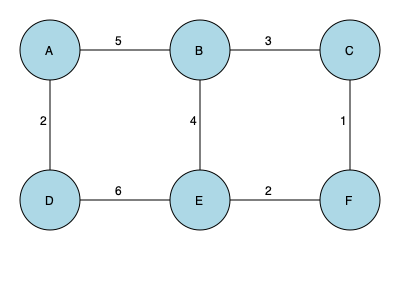Given the network topology represented by the graph above, where nodes represent servers and edge weights represent latency in milliseconds, what is the minimum spanning tree (MST) weight that ensures optimal connectivity with minimal total latency? To find the minimum spanning tree (MST) weight, we'll use Kruskal's algorithm:

1. Sort edges by weight (ascending):
   C-F (1), A-D (2), E-F (2), B-C (3), B-E (4), A-B (5), D-E (6)

2. Initialize MST: empty set

3. Iterate through sorted edges:
   a) C-F (1): Add to MST
   b) A-D (2): Add to MST
   c) E-F (2): Add to MST
   d) B-C (3): Add to MST
   e) B-E (4): Skip (would create a cycle)
   f) A-B (5): Skip (would create a cycle)
   g) D-E (6): Skip (would create a cycle)

4. The MST now contains edges: C-F, A-D, E-F, B-C

5. Calculate total weight:
   $MST_{weight} = 1 + 2 + 2 + 3 = 8$

Therefore, the minimum spanning tree weight is 8 milliseconds.
Answer: 8 milliseconds 